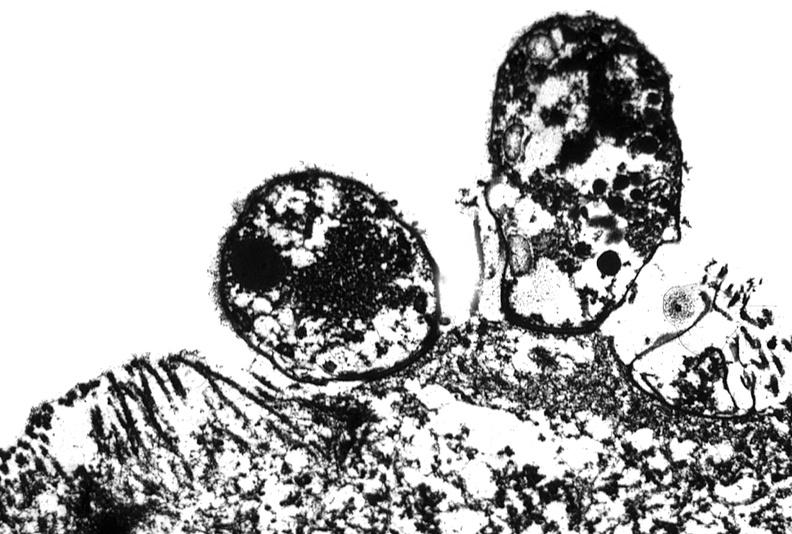s anencephaly present?
Answer the question using a single word or phrase. No 